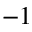<formula> <loc_0><loc_0><loc_500><loc_500>^ { - 1 }</formula> 